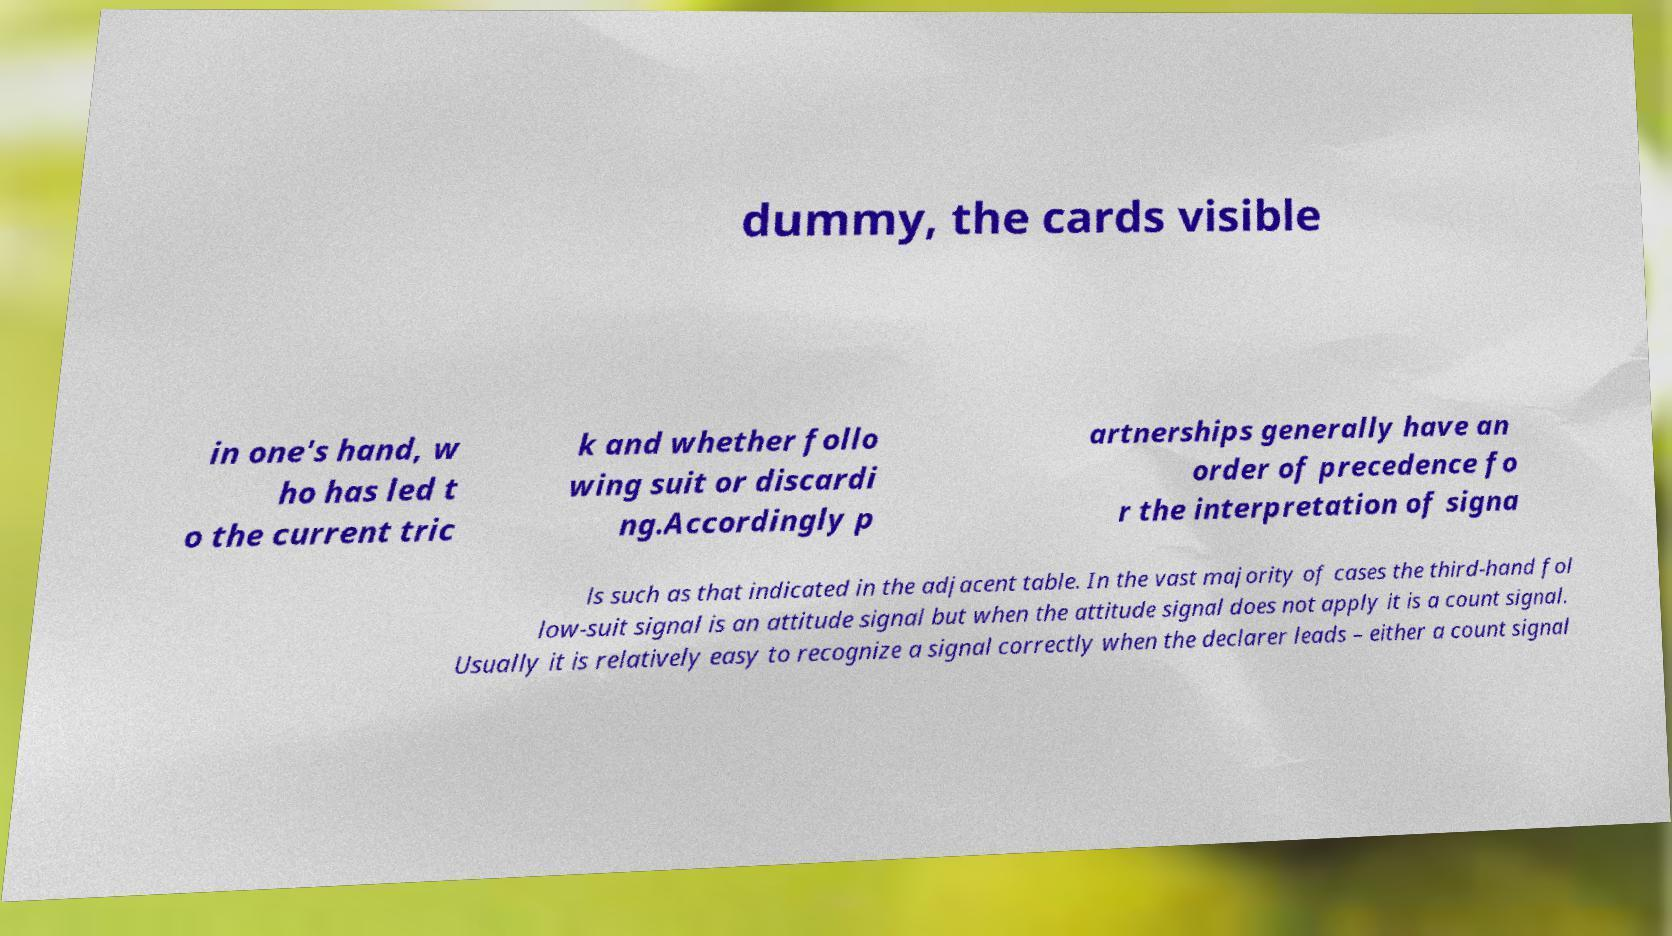Can you accurately transcribe the text from the provided image for me? dummy, the cards visible in one's hand, w ho has led t o the current tric k and whether follo wing suit or discardi ng.Accordingly p artnerships generally have an order of precedence fo r the interpretation of signa ls such as that indicated in the adjacent table. In the vast majority of cases the third-hand fol low-suit signal is an attitude signal but when the attitude signal does not apply it is a count signal. Usually it is relatively easy to recognize a signal correctly when the declarer leads – either a count signal 